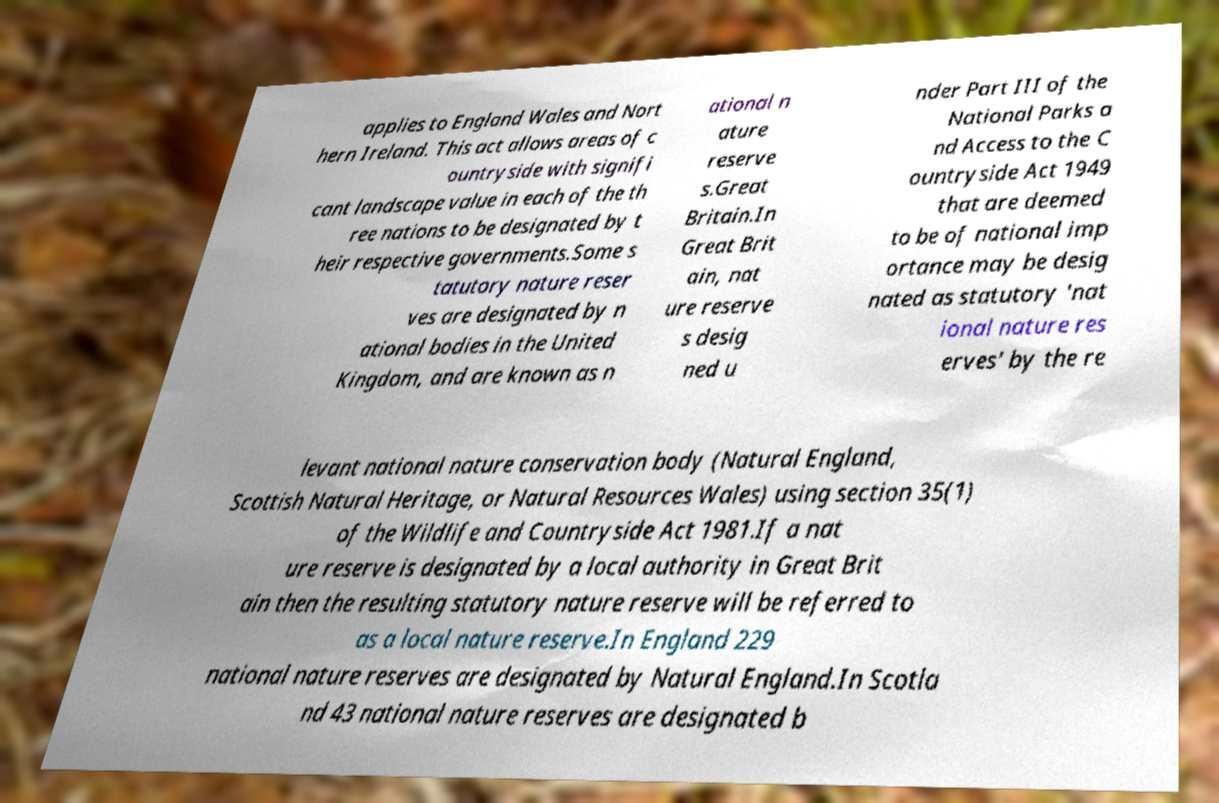Please read and relay the text visible in this image. What does it say? applies to England Wales and Nort hern Ireland. This act allows areas of c ountryside with signifi cant landscape value in each of the th ree nations to be designated by t heir respective governments.Some s tatutory nature reser ves are designated by n ational bodies in the United Kingdom, and are known as n ational n ature reserve s.Great Britain.In Great Brit ain, nat ure reserve s desig ned u nder Part III of the National Parks a nd Access to the C ountryside Act 1949 that are deemed to be of national imp ortance may be desig nated as statutory 'nat ional nature res erves' by the re levant national nature conservation body (Natural England, Scottish Natural Heritage, or Natural Resources Wales) using section 35(1) of the Wildlife and Countryside Act 1981.If a nat ure reserve is designated by a local authority in Great Brit ain then the resulting statutory nature reserve will be referred to as a local nature reserve.In England 229 national nature reserves are designated by Natural England.In Scotla nd 43 national nature reserves are designated b 